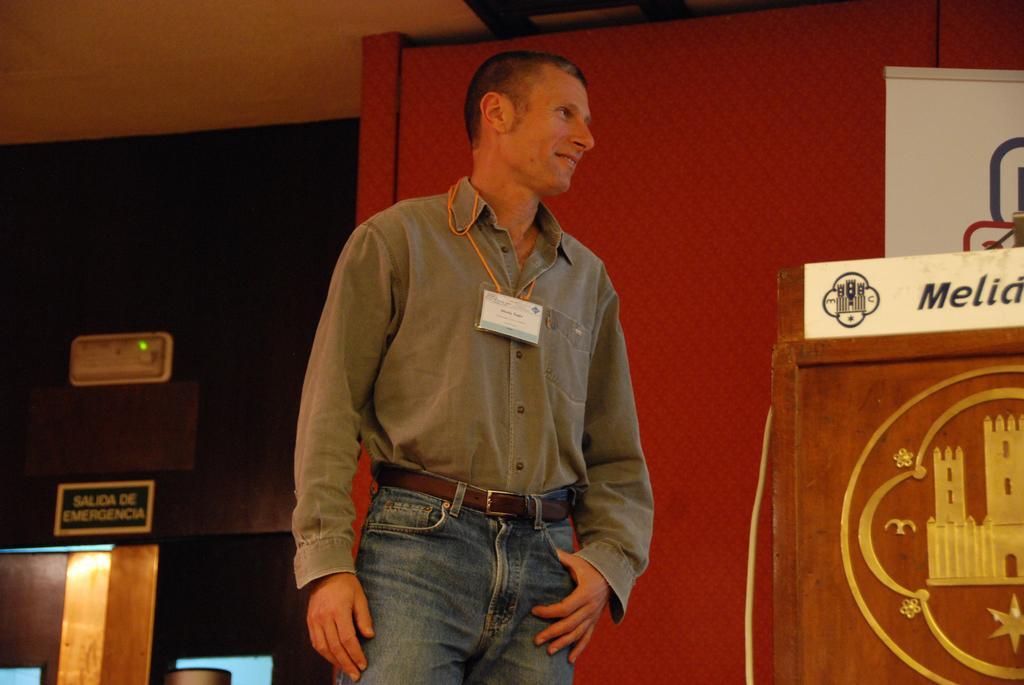Could you give a brief overview of what you see in this image? In this image in the front there is a man standing and smiling. In the background on the right side there is a board with some text written on it. On the left side there is a wall which is black in colour with some text written on it. 